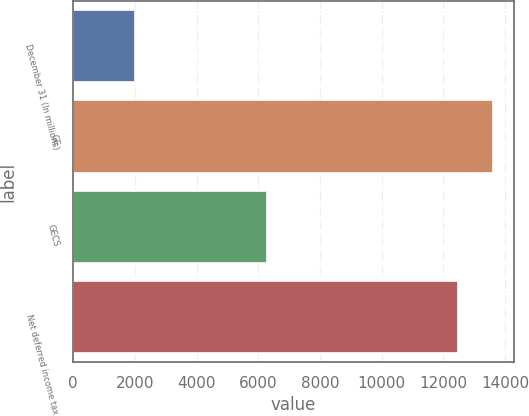Convert chart. <chart><loc_0><loc_0><loc_500><loc_500><bar_chart><fcel>December 31 (In millions)<fcel>GE<fcel>GECS<fcel>Net deferred income tax<nl><fcel>2007<fcel>13601.5<fcel>6293<fcel>12490<nl></chart> 